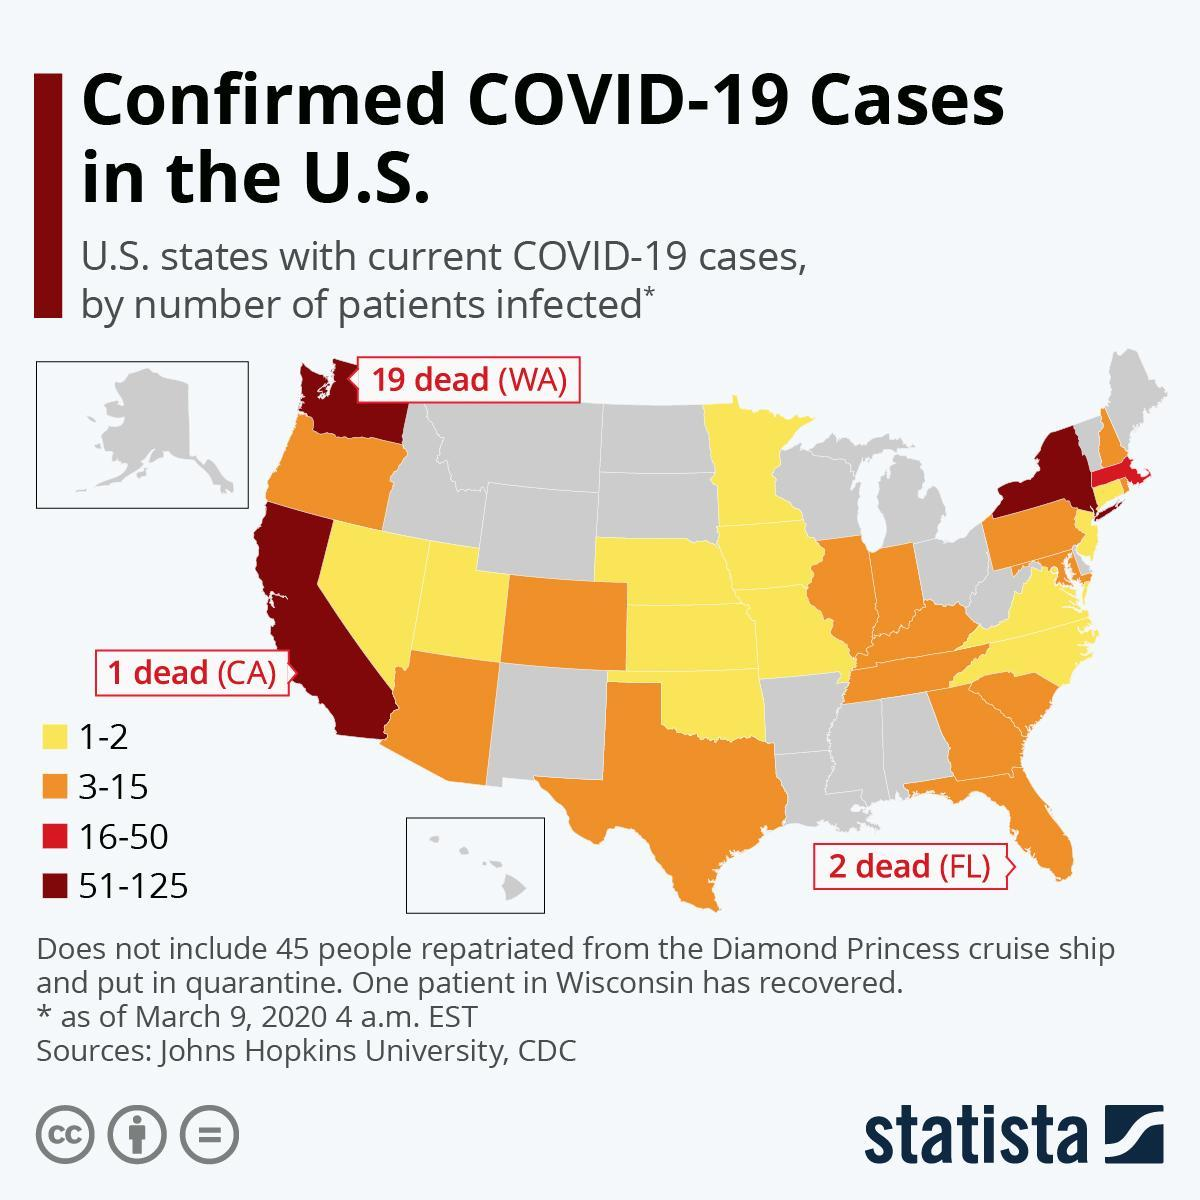By what colour is the states having 1-2 patients represented- red, grey or yellow?
Answer the question with a short phrase. yellow How many states have 51-125 patients infected? 3 How many patients have been in infected in states coloured orange? 3-15 Among the states marked on the map, which state has highest number of deaths? WA 